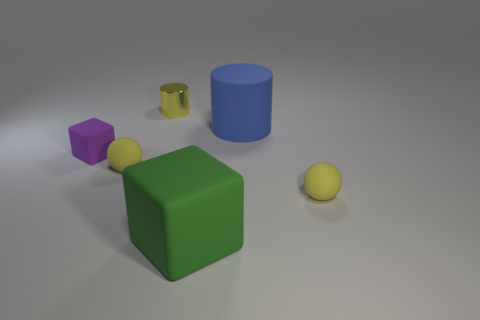How many yellow balls must be subtracted to get 1 yellow balls? 1 Add 1 small matte things. How many objects exist? 7 Subtract all cylinders. How many objects are left? 4 Add 1 small blocks. How many small blocks exist? 2 Subtract 2 yellow balls. How many objects are left? 4 Subtract all yellow balls. Subtract all big green objects. How many objects are left? 3 Add 4 yellow shiny cylinders. How many yellow shiny cylinders are left? 5 